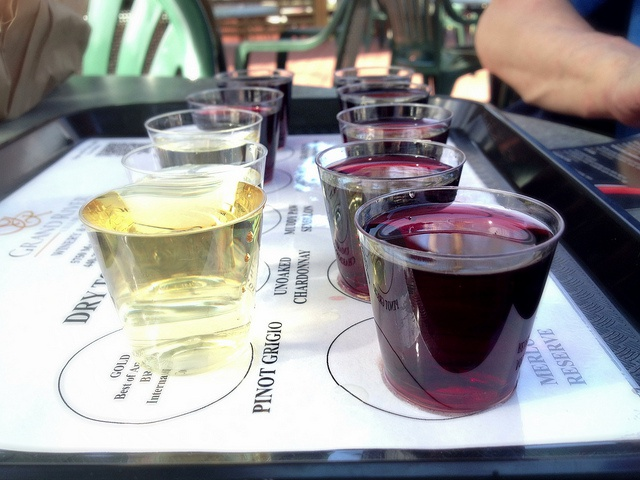Describe the objects in this image and their specific colors. I can see dining table in white, brown, black, gray, and darkgray tones, cup in brown, black, gray, purple, and darkgray tones, cup in brown, beige, khaki, olive, and tan tones, people in brown, tan, and black tones, and cup in brown, gray, darkgray, lightgray, and purple tones in this image. 